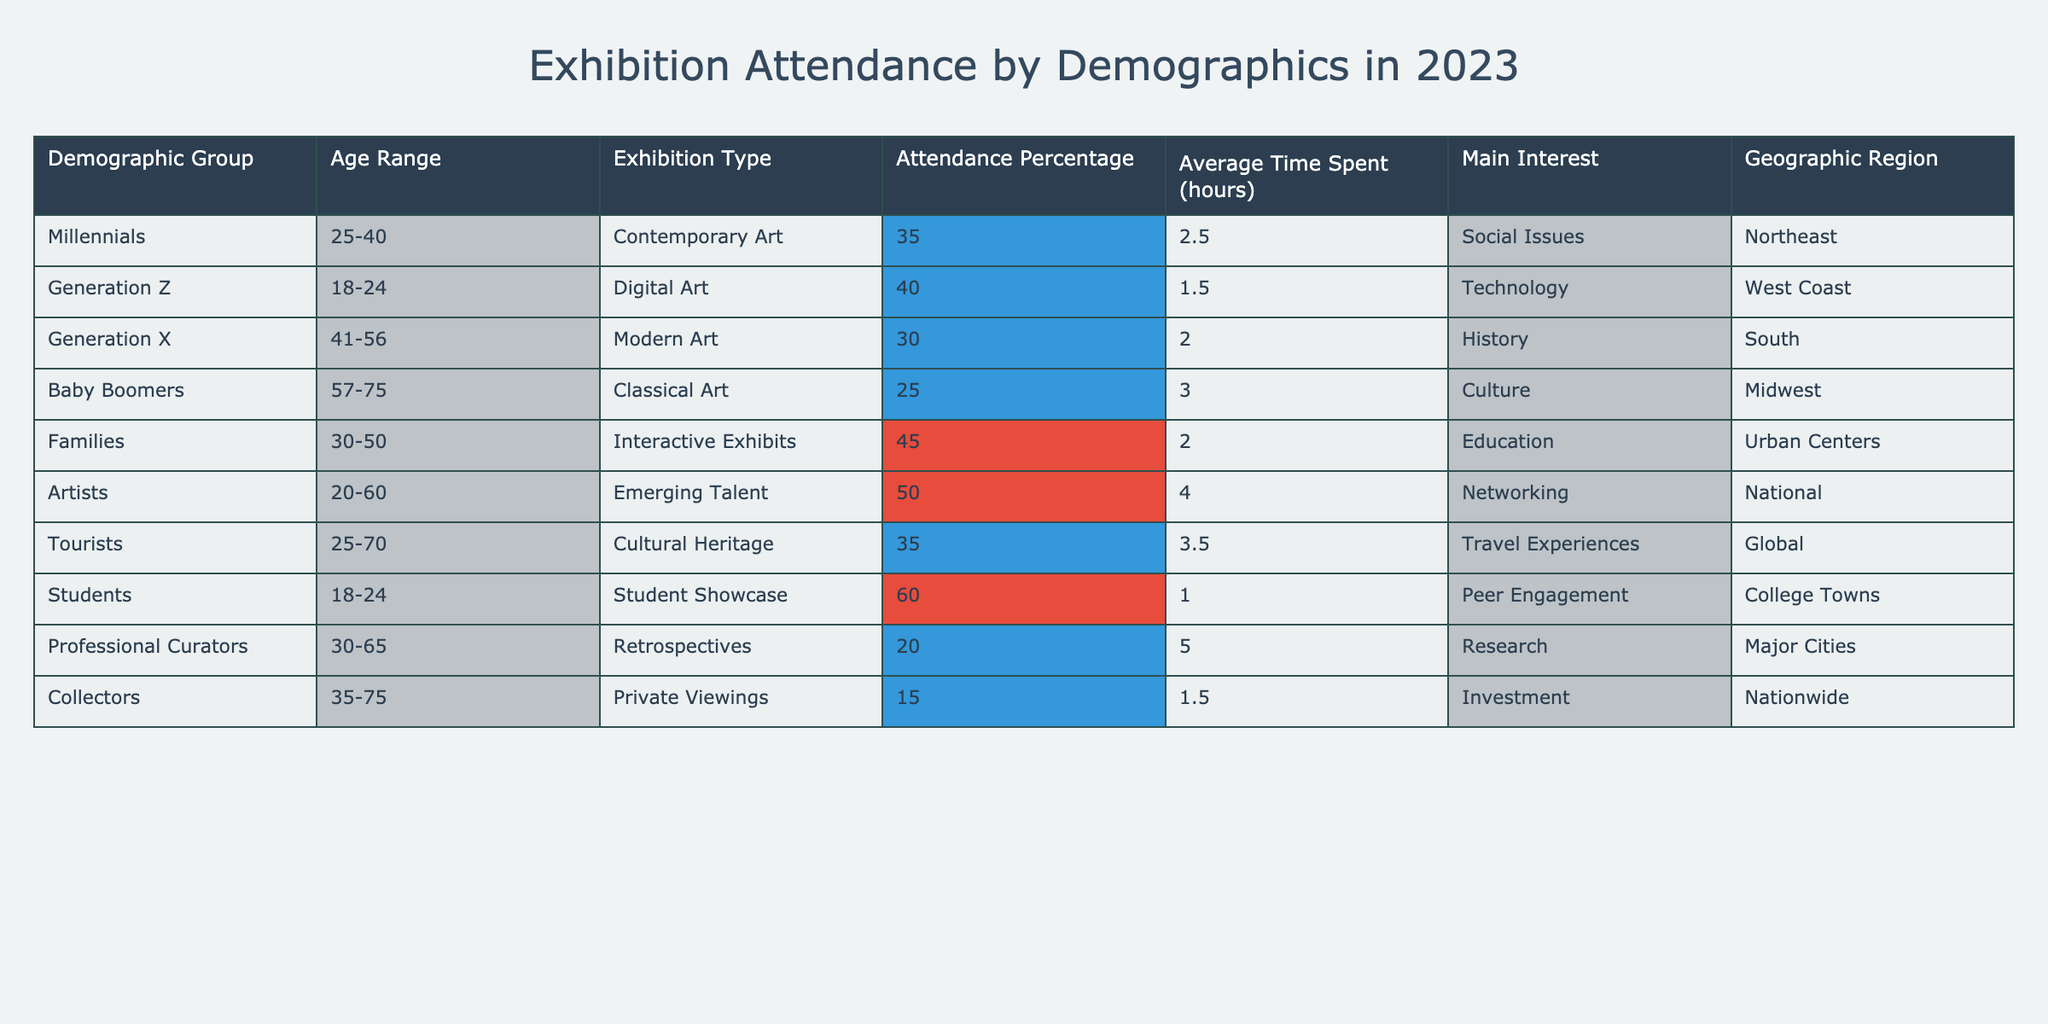What demographic group has the highest attendance percentage? According to the table, the group with the highest attendance percentage is Students at 60%.
Answer: Students What is the average time spent by Baby Boomers at the exhibition? The average time spent by Baby Boomers is 3.0 hours, as stated in the table.
Answer: 3.0 hours Which demographic group is most interested in networking? The demographic group most interested in networking is Artists, with an average time spent of 4.0 hours.
Answer: Artists How many demographic groups have an attendance percentage above 40%? There are three groups above 40%: Students (60%), Families (45%), and Artists (50%).
Answer: 3 Is it true that Generation Z has a higher attendance percentage than Baby Boomers? Yes, Generation Z has an attendance percentage of 40%, which is higher than Baby Boomers' 25%.
Answer: Yes What is the total attendance percentage of all demographic groups combined? The total attendance percentage is not a straightforward sum since it represents different samples. However, there are 10 data points, and averaging them provides an insight into overall trends rather than total.
Answer: Not applicable Which demographic group spends the least amount of time at the exhibitions? Students spend the least amount of time at the exhibitions, averaging 1.0 hours.
Answer: Students What is the difference in average time spent at exhibitions between Professional Curators and Families? Professional Curators spend an average of 5.0 hours, while Families spend 2.0 hours. The difference is 5.0 - 2.0 = 3.0 hours.
Answer: 3.0 hours Which demographic group has the lowest attendance percentage and what is it? Collectors have the lowest attendance percentage at 15%.
Answer: Collectors, 15% Comparing Millennials and Generation X, which group has a higher average time spent at the exhibition? Millennials spend an average of 2.5 hours, while Generation X spends 2.0 hours. Therefore, Millennials have a higher average time spent.
Answer: Millennials 